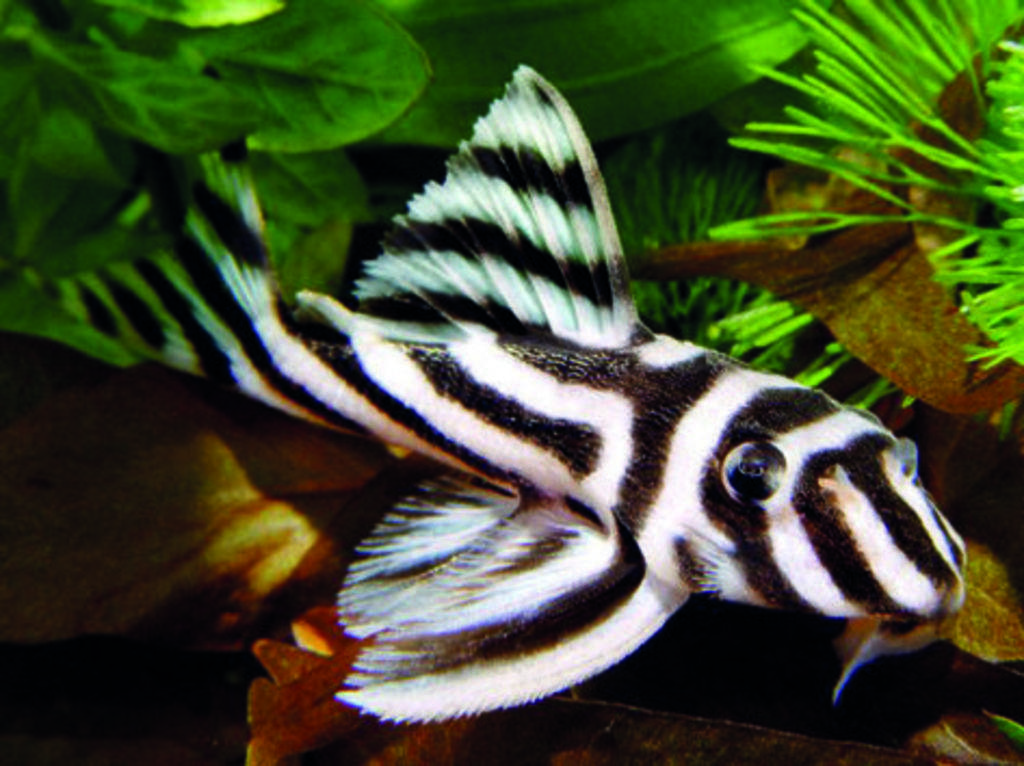What type of animal is present in the image? There is a fish in the image. What other living organisms can be seen in the image? There are plants in the image. What type of shoe is visible in the image? There is no shoe present in the image. How many cattle can be seen in the image? There are no cattle present in the image. 